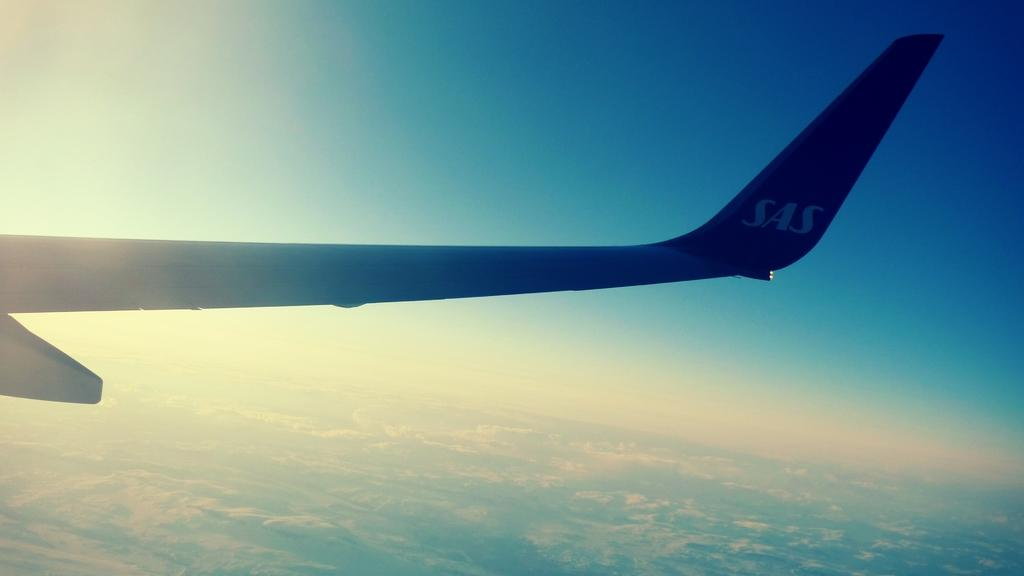<image>
Write a terse but informative summary of the picture. a plane that says 'sas' on the side of it 